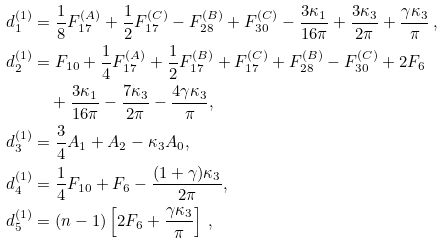Convert formula to latex. <formula><loc_0><loc_0><loc_500><loc_500>d ^ { ( 1 ) } _ { 1 } & = \frac { 1 } { 8 } F _ { 1 7 } ^ { ( A ) } + \frac { 1 } { 2 } F _ { 1 7 } ^ { ( C ) } - F _ { 2 8 } ^ { ( B ) } + F _ { 3 0 } ^ { ( C ) } - \frac { 3 \kappa _ { 1 } } { 1 6 \pi } + \frac { 3 \kappa _ { 3 } } { 2 \pi } + \frac { \gamma \kappa _ { 3 } } { \pi } \, , \\ d ^ { ( 1 ) } _ { 2 } & = F _ { 1 0 } + \frac { 1 } { 4 } F _ { 1 7 } ^ { ( A ) } + \frac { 1 } { 2 } F _ { 1 7 } ^ { ( B ) } + F _ { 1 7 } ^ { ( C ) } + F _ { 2 8 } ^ { ( B ) } - F _ { 3 0 } ^ { ( C ) } + 2 F _ { 6 } \\ & \quad + \frac { 3 \kappa _ { 1 } } { 1 6 \pi } - \frac { 7 \kappa _ { 3 } } { 2 \pi } - \frac { 4 \gamma \kappa _ { 3 } } { \pi } , \\ d ^ { ( 1 ) } _ { 3 } & = \frac { 3 } { 4 } A _ { 1 } + A _ { 2 } - \kappa _ { 3 } A _ { 0 } , \\ d ^ { ( 1 ) } _ { 4 } & = \frac { 1 } { 4 } F _ { 1 0 } + F _ { 6 } - \frac { ( 1 + \gamma ) \kappa _ { 3 } } { 2 \pi } , \\ d ^ { ( 1 ) } _ { 5 } & = ( n - 1 ) \left [ 2 F _ { 6 } + \frac { \gamma \kappa _ { 3 } } { \pi } \right ] \, ,</formula> 